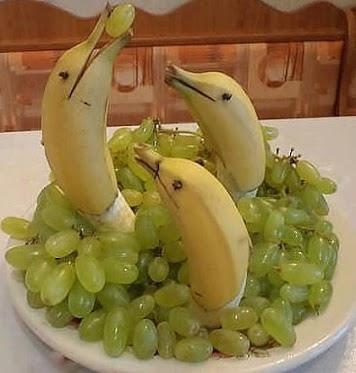What color are the grapes?
Give a very brief answer. Green. What animal do the bananas look like?
Write a very short answer. Dolphins. How many banana dolphins are there?
Short answer required. 3. 